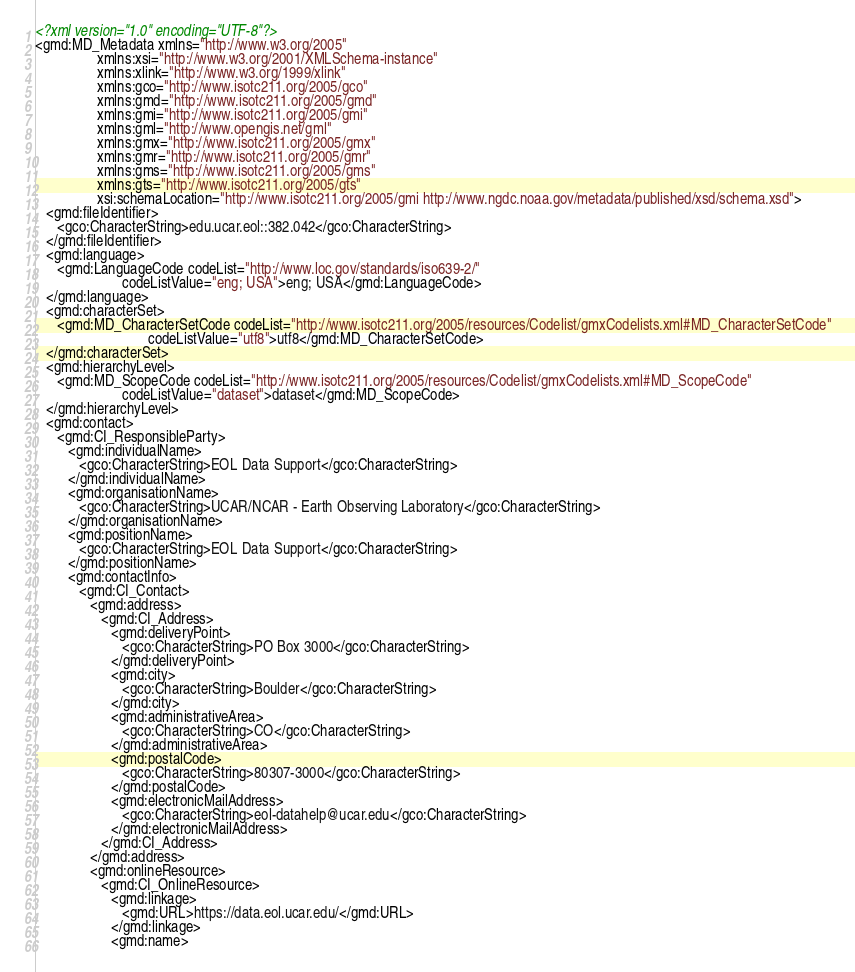<code> <loc_0><loc_0><loc_500><loc_500><_XML_><?xml version="1.0" encoding="UTF-8"?>
<gmd:MD_Metadata xmlns="http://www.w3.org/2005"
                 xmlns:xsi="http://www.w3.org/2001/XMLSchema-instance"
                 xmlns:xlink="http://www.w3.org/1999/xlink"
                 xmlns:gco="http://www.isotc211.org/2005/gco"
                 xmlns:gmd="http://www.isotc211.org/2005/gmd"
                 xmlns:gmi="http://www.isotc211.org/2005/gmi"
                 xmlns:gml="http://www.opengis.net/gml"
                 xmlns:gmx="http://www.isotc211.org/2005/gmx"
                 xmlns:gmr="http://www.isotc211.org/2005/gmr"
                 xmlns:gms="http://www.isotc211.org/2005/gms"
                 xmlns:gts="http://www.isotc211.org/2005/gts"
                 xsi:schemaLocation="http://www.isotc211.org/2005/gmi http://www.ngdc.noaa.gov/metadata/published/xsd/schema.xsd">
   <gmd:fileIdentifier>
      <gco:CharacterString>edu.ucar.eol::382.042</gco:CharacterString>
   </gmd:fileIdentifier>
   <gmd:language>
      <gmd:LanguageCode codeList="http://www.loc.gov/standards/iso639-2/"
                        codeListValue="eng; USA">eng; USA</gmd:LanguageCode>
   </gmd:language>
   <gmd:characterSet>
      <gmd:MD_CharacterSetCode codeList="http://www.isotc211.org/2005/resources/Codelist/gmxCodelists.xml#MD_CharacterSetCode"
                               codeListValue="utf8">utf8</gmd:MD_CharacterSetCode>
   </gmd:characterSet>
   <gmd:hierarchyLevel>
      <gmd:MD_ScopeCode codeList="http://www.isotc211.org/2005/resources/Codelist/gmxCodelists.xml#MD_ScopeCode"
                        codeListValue="dataset">dataset</gmd:MD_ScopeCode>
   </gmd:hierarchyLevel>
   <gmd:contact>
      <gmd:CI_ResponsibleParty>
         <gmd:individualName>
            <gco:CharacterString>EOL Data Support</gco:CharacterString>
         </gmd:individualName>
         <gmd:organisationName>
            <gco:CharacterString>UCAR/NCAR - Earth Observing Laboratory</gco:CharacterString>
         </gmd:organisationName>
         <gmd:positionName>
            <gco:CharacterString>EOL Data Support</gco:CharacterString>
         </gmd:positionName>
         <gmd:contactInfo>
            <gmd:CI_Contact>
               <gmd:address>
                  <gmd:CI_Address>
                     <gmd:deliveryPoint>
                        <gco:CharacterString>PO Box 3000</gco:CharacterString>
                     </gmd:deliveryPoint>
                     <gmd:city>
                        <gco:CharacterString>Boulder</gco:CharacterString>
                     </gmd:city>
                     <gmd:administrativeArea>
                        <gco:CharacterString>CO</gco:CharacterString>
                     </gmd:administrativeArea>
                     <gmd:postalCode>
                        <gco:CharacterString>80307-3000</gco:CharacterString>
                     </gmd:postalCode>
                     <gmd:electronicMailAddress>
                        <gco:CharacterString>eol-datahelp@ucar.edu</gco:CharacterString>
                     </gmd:electronicMailAddress>
                  </gmd:CI_Address>
               </gmd:address>
               <gmd:onlineResource>
                  <gmd:CI_OnlineResource>
                     <gmd:linkage>
                        <gmd:URL>https://data.eol.ucar.edu/</gmd:URL>
                     </gmd:linkage>
                     <gmd:name></code> 